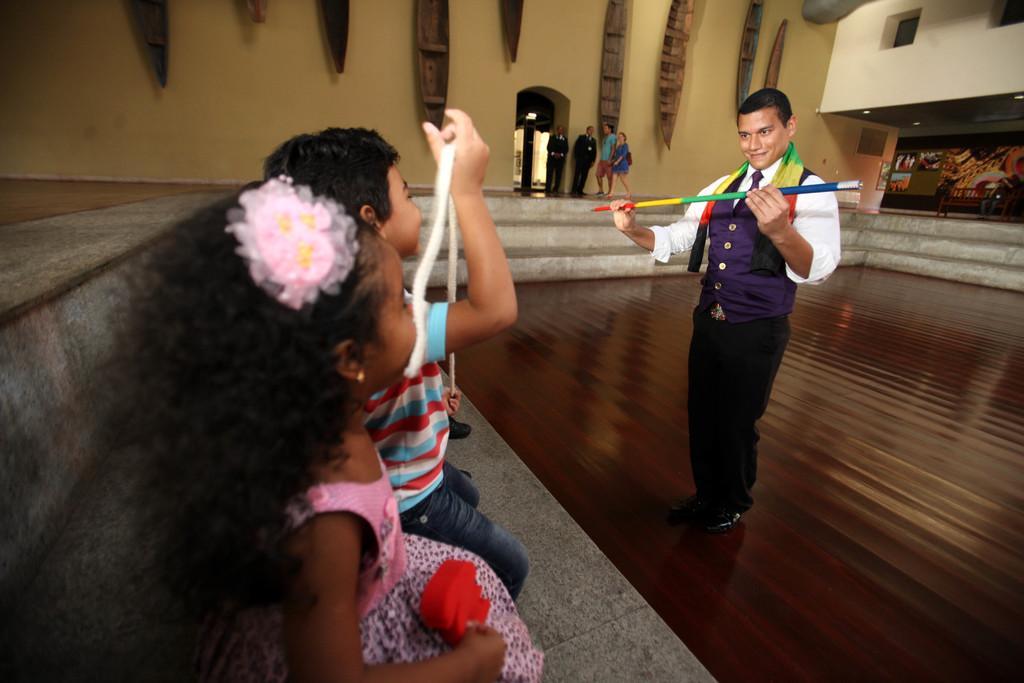In one or two sentences, can you explain what this image depicts? In the picture we can see a hall with a wooden floor on it we can see a man standing and holding a stick with two hands, the stick is with different colors and front of him we can see a boy and a girl sitting on a bench and watching him, and in the background we can see a wall with door and near it we can see two men and a man and woman are walking and besides we can see a stage with some decorations and to the ceiling we can see some lights. 